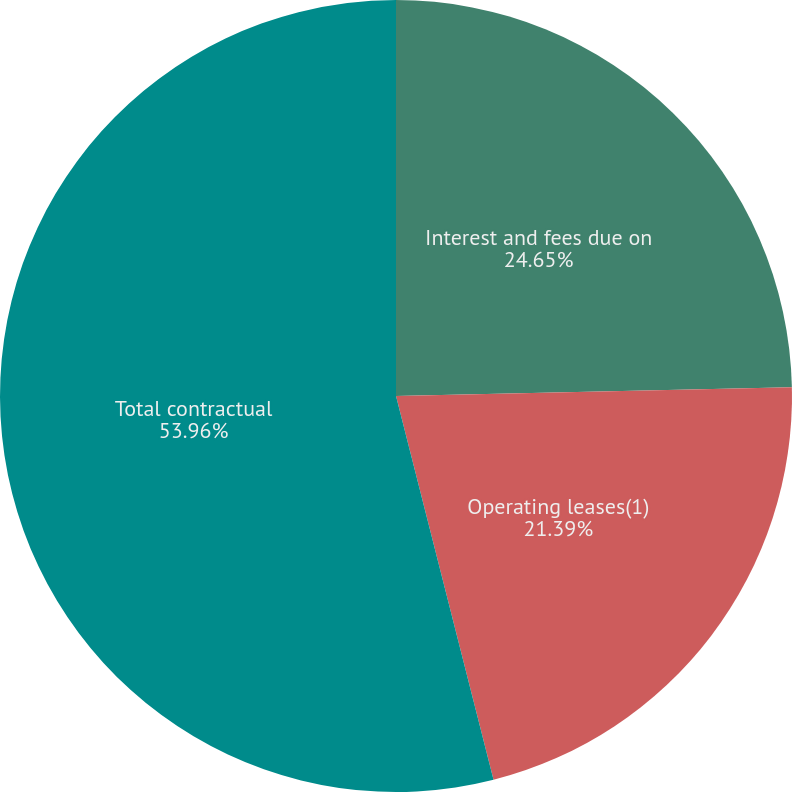Convert chart. <chart><loc_0><loc_0><loc_500><loc_500><pie_chart><fcel>Interest and fees due on<fcel>Operating leases(1)<fcel>Total contractual<nl><fcel>24.65%<fcel>21.39%<fcel>53.96%<nl></chart> 